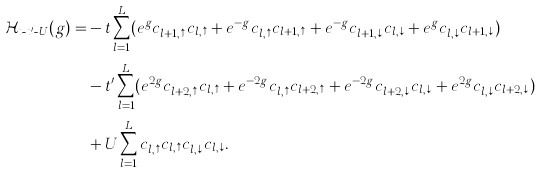Convert formula to latex. <formula><loc_0><loc_0><loc_500><loc_500>\mathcal { H } _ { t \text {-} t ^ { \prime } \text {-} U } ( g ) = & - t \sum _ { l = 1 } ^ { L } ( e ^ { g } c _ { l + 1 , \uparrow } ^ { \dag } c _ { l , \uparrow } + e ^ { - g } c _ { l , \uparrow } ^ { \dag } c _ { l + 1 , \uparrow } + e ^ { - g } c _ { l + 1 , \downarrow } ^ { \dag } c _ { l , \downarrow } + e ^ { g } c _ { l , \downarrow } ^ { \dag } c _ { l + 1 , \downarrow } ) \\ & - t ^ { \prime } \sum _ { l = 1 } ^ { L } ( e ^ { 2 g } c _ { l + 2 , \uparrow } ^ { \dag } c _ { l , \uparrow } + e ^ { - 2 g } c _ { l , \uparrow } ^ { \dag } c _ { l + 2 , \uparrow } + e ^ { - 2 g } c _ { l + 2 , \downarrow } ^ { \dag } c _ { l , \downarrow } + e ^ { 2 g } c _ { l , \downarrow } ^ { \dag } c _ { l + 2 , \downarrow } ) \\ & + U \sum _ { l = 1 } ^ { L } c _ { l , \uparrow } ^ { \dag } c _ { l , \uparrow } c _ { l , \downarrow } ^ { \dag } c _ { l , \downarrow } .</formula> 